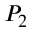Convert formula to latex. <formula><loc_0><loc_0><loc_500><loc_500>P _ { 2 }</formula> 